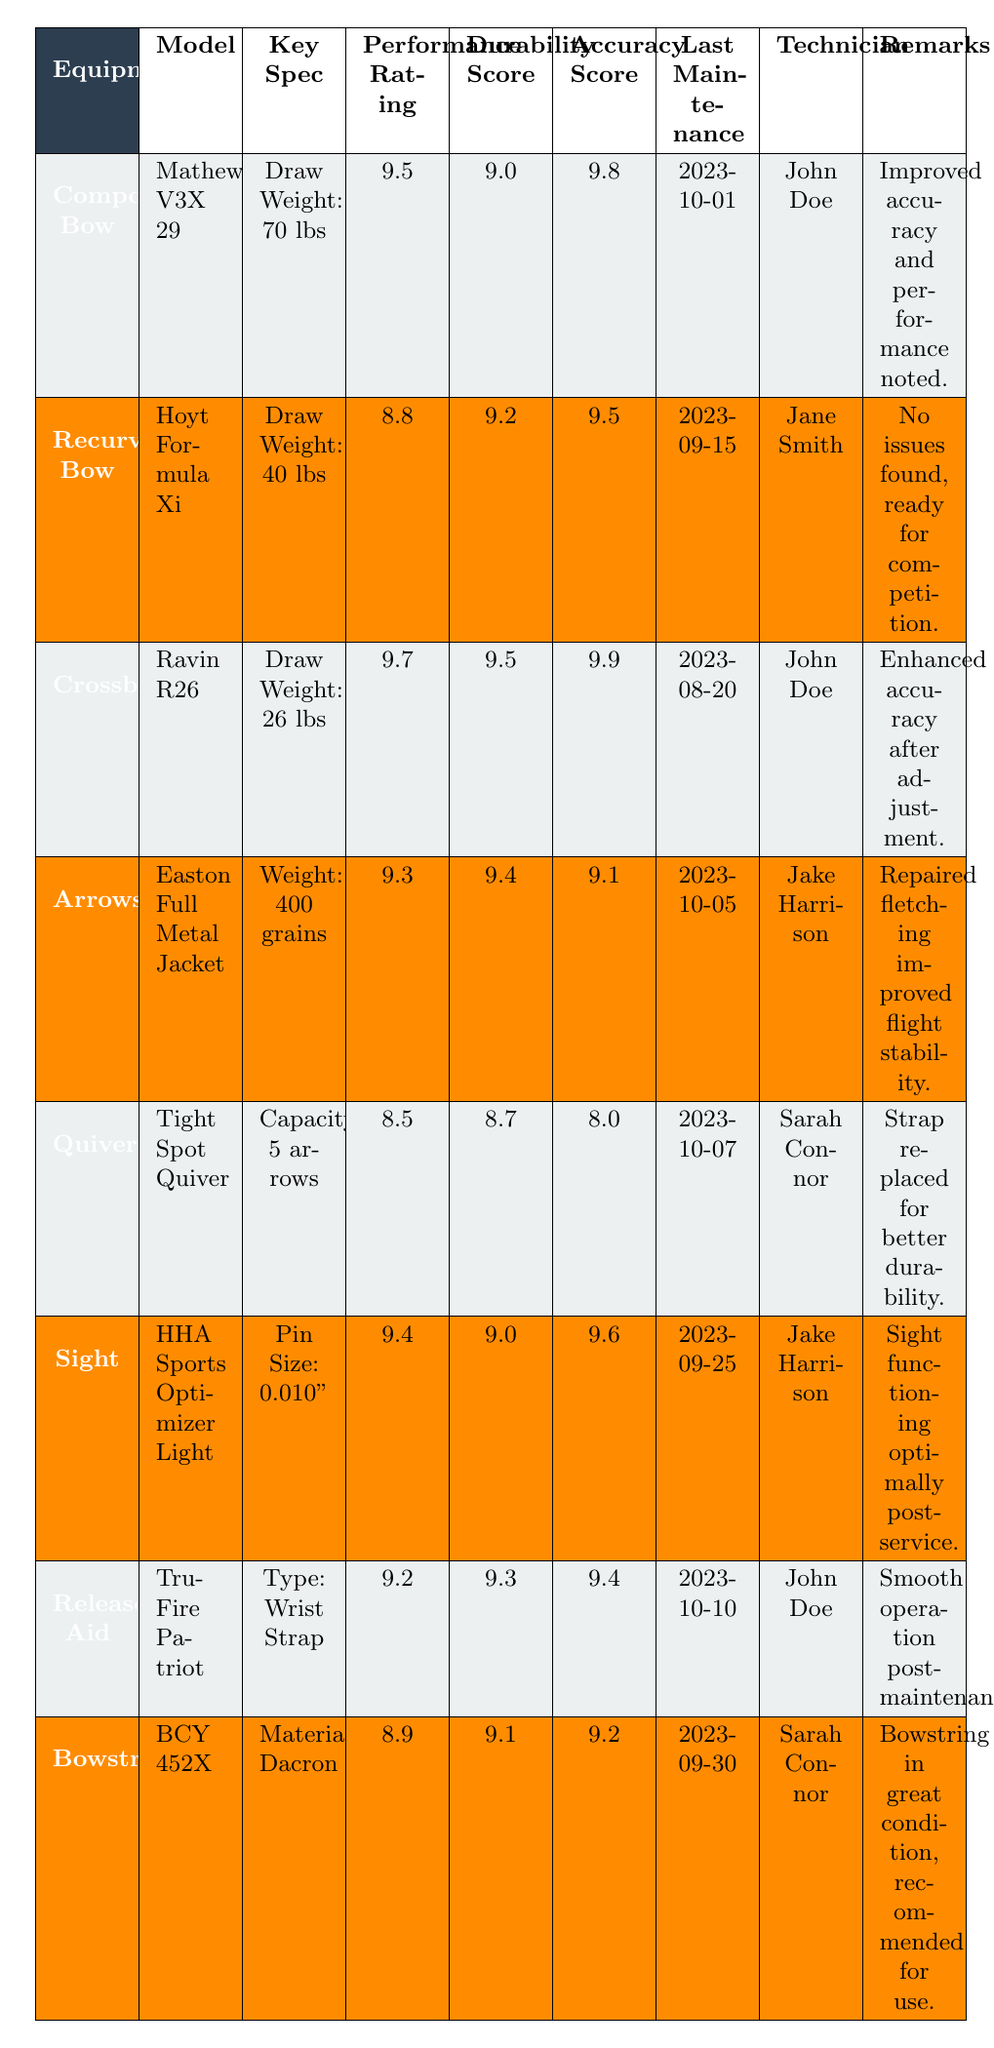What is the Performance Rating of the Compound Bow? The Performance Rating of the Compound Bow, specifically the Mathews V3X 29, is listed in the table as 9.5.
Answer: 9.5 What maintenance was performed on the Recurve Bow? The maintenance log shows that on 2023-09-15, General inspection and limb alignment were performed on the Recurve Bow.
Answer: General inspection, limb alignment Which equipment has the highest Accuracy Score? By reviewing the Accuracy Scores in the table, the Crossbow (Ravin R26) has the highest Accuracy Score of 9.9.
Answer: Crossbow (Ravin R26) Who conducted the last maintenance on the Arrows? Referring to the maintenance logs, Jake Harrison performed maintenance on the Arrows on 2023-10-05.
Answer: Jake Harrison What is the average Performance Rating of all equipment types? The Performance Ratings are 9.5, 8.8, 9.7, 9.3, 8.5, 9.4, 9.2, and 8.9. The sum is 73.3 and there are 8 pieces of equipment, so the average is 73.3 / 8 = 9.1625, which rounds to 9.2.
Answer: 9.2 Did the technician for the Crossbow perform any specific adjustments? Yes, on the maintenance date of 2023-08-20, John Doe performed trigger adjustment and scope calibration on the Crossbow, indicating specific adjustments were made.
Answer: Yes How many equipment types have a Durability Score of 9.0 or higher? By counting the Durability Scores in the table, we find that there are 6 equipment types with scores of 9.0 or above: Compound Bow, Recurve Bow, Crossbow, Arrows, Sight, and Release Aid.
Answer: 6 Is the last maintenance for the Bowstring performed by Sarah Connor? The last maintenance for the Bowstring was performed on 2023-09-30, and the technician listed is Sarah Connor, making the statement true.
Answer: Yes What was the main issue noted after the maintenance of the Compound Bow? After the maintenance on 2023-10-01, the remarks indicated that improved accuracy and performance were noted, implying the maintenance successfully addressed its issues.
Answer: Improved accuracy and performance If you combine the Performance Ratings of the Recurve Bow and Quiver, what is the total? The Performance Ratings for the Recurve Bow (8.8) and Quiver (8.5) sum to 8.8 + 8.5 = 17.3.
Answer: 17.3 